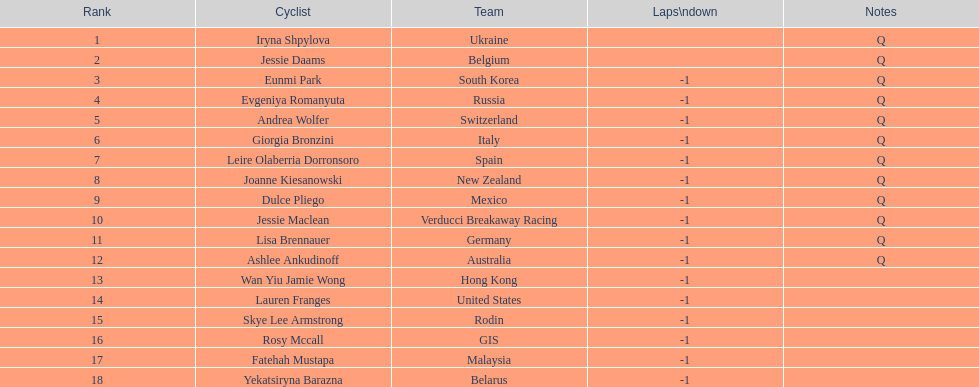Which team can be found preceding belgium? Ukraine. 